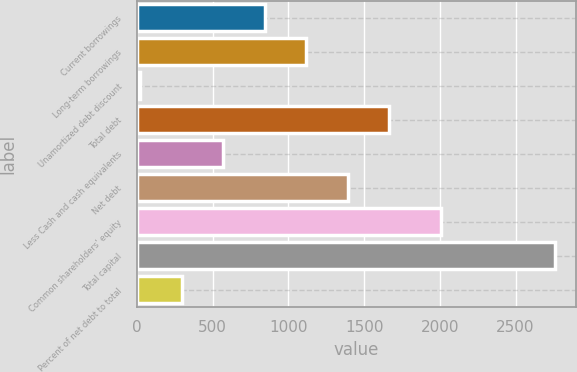Convert chart. <chart><loc_0><loc_0><loc_500><loc_500><bar_chart><fcel>Current borrowings<fcel>Long-term borrowings<fcel>Unamortized debt discount<fcel>Total debt<fcel>Less Cash and cash equivalents<fcel>Net debt<fcel>Common shareholders' equity<fcel>Total capital<fcel>Percent of net debt to total<nl><fcel>844.04<fcel>1117.72<fcel>23<fcel>1665.08<fcel>570.36<fcel>1391.4<fcel>2009.3<fcel>2759.8<fcel>296.68<nl></chart> 